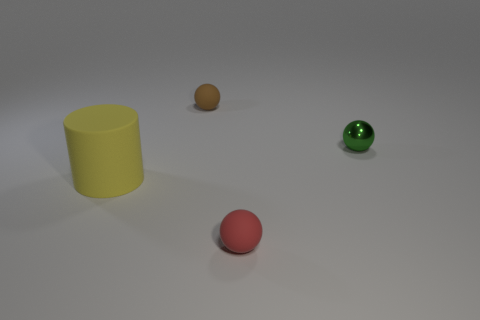Can you describe the colors of the objects starting from the left? Certainly! Starting from the left, we have a matte yellow cylinder, followed by a small brown sphere, then a shiny green sphere, and lastly, a matte red sphere in the foreground. 